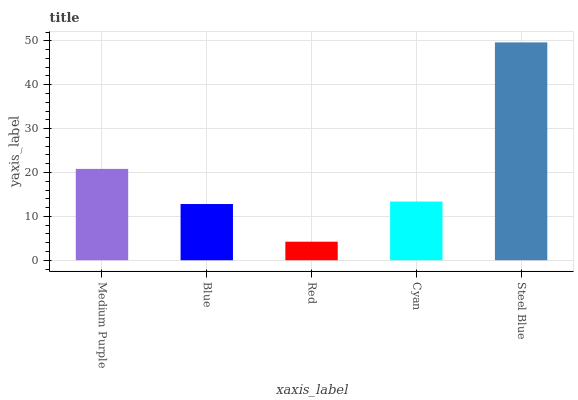Is Red the minimum?
Answer yes or no. Yes. Is Steel Blue the maximum?
Answer yes or no. Yes. Is Blue the minimum?
Answer yes or no. No. Is Blue the maximum?
Answer yes or no. No. Is Medium Purple greater than Blue?
Answer yes or no. Yes. Is Blue less than Medium Purple?
Answer yes or no. Yes. Is Blue greater than Medium Purple?
Answer yes or no. No. Is Medium Purple less than Blue?
Answer yes or no. No. Is Cyan the high median?
Answer yes or no. Yes. Is Cyan the low median?
Answer yes or no. Yes. Is Blue the high median?
Answer yes or no. No. Is Blue the low median?
Answer yes or no. No. 